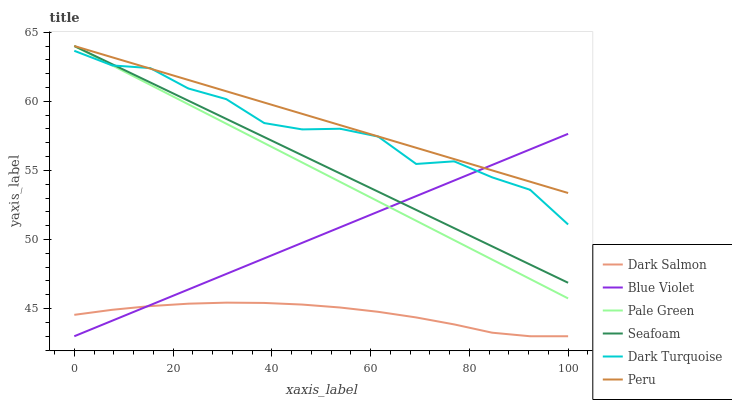Does Seafoam have the minimum area under the curve?
Answer yes or no. No. Does Seafoam have the maximum area under the curve?
Answer yes or no. No. Is Dark Salmon the smoothest?
Answer yes or no. No. Is Dark Salmon the roughest?
Answer yes or no. No. Does Seafoam have the lowest value?
Answer yes or no. No. Does Dark Salmon have the highest value?
Answer yes or no. No. Is Dark Salmon less than Dark Turquoise?
Answer yes or no. Yes. Is Seafoam greater than Dark Salmon?
Answer yes or no. Yes. Does Dark Salmon intersect Dark Turquoise?
Answer yes or no. No. 